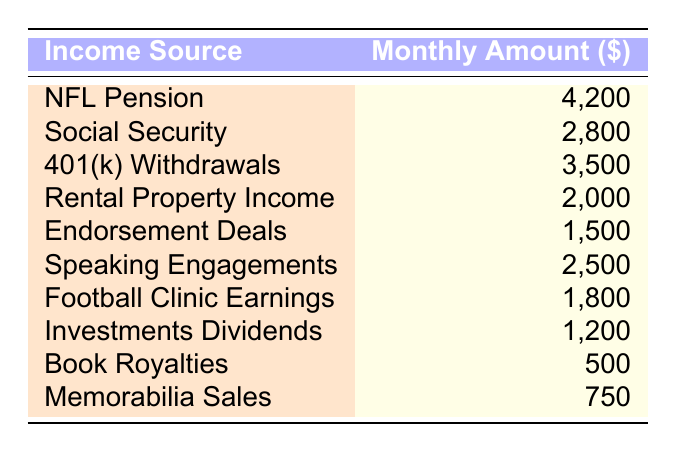What is the highest source of monthly income? The table shows various income sources with their corresponding monthly amounts. The highest amount listed among them is NFL Pension, which is $4,200.
Answer: $4,200 How much do you receive from Social Security? The table includes a row for Social Security, showing a monthly amount of $2,800.
Answer: $2,800 What is the total amount from 401(k) Withdrawals and Rental Property Income? To find this total, I will sum the amounts: 401(k) Withdrawals is $3,500, and Rental Property Income is $2,000. Adding these two together gives me $3,500 + $2,000 = $5,500.
Answer: $5,500 Is the income from Speaking Engagements greater than the income from Endorsement Deals? According to the table, Speaking Engagements generate $2,500, while Endorsement Deals generate $1,500. Since $2,500 is greater than $1,500, the answer is yes.
Answer: Yes What is the average monthly income from the Football Clinic Earnings and Book Royalties? First, I identify the amounts: Football Clinic Earnings is $1,800, and Book Royalties is $500. Next, I sum these two amounts: $1,800 + $500 = $2,300. Then, I divide by the number of sources which is 2: $2,300 / 2 = $1,150.
Answer: $1,150 What is the total monthly income from all sources? To calculate the total income, I will sum all the provided monthly amounts from the table: $4,200 + $2,800 + $3,500 + $2,000 + $1,500 + $2,500 + $1,800 + $1,200 + $500 + $750 = $20,750. This involves adding up each income source.
Answer: $20,750 Is the monthly income from Investments Dividends less than $1,500? The table shows that Investments Dividends amount to $1,200. Since $1,200 is less than $1,500, the answer is yes.
Answer: Yes Which income source contributes the least amount monthly? By reviewing the table, I can see that the least amount is from Book Royalties, which is $500.
Answer: Book Royalties 